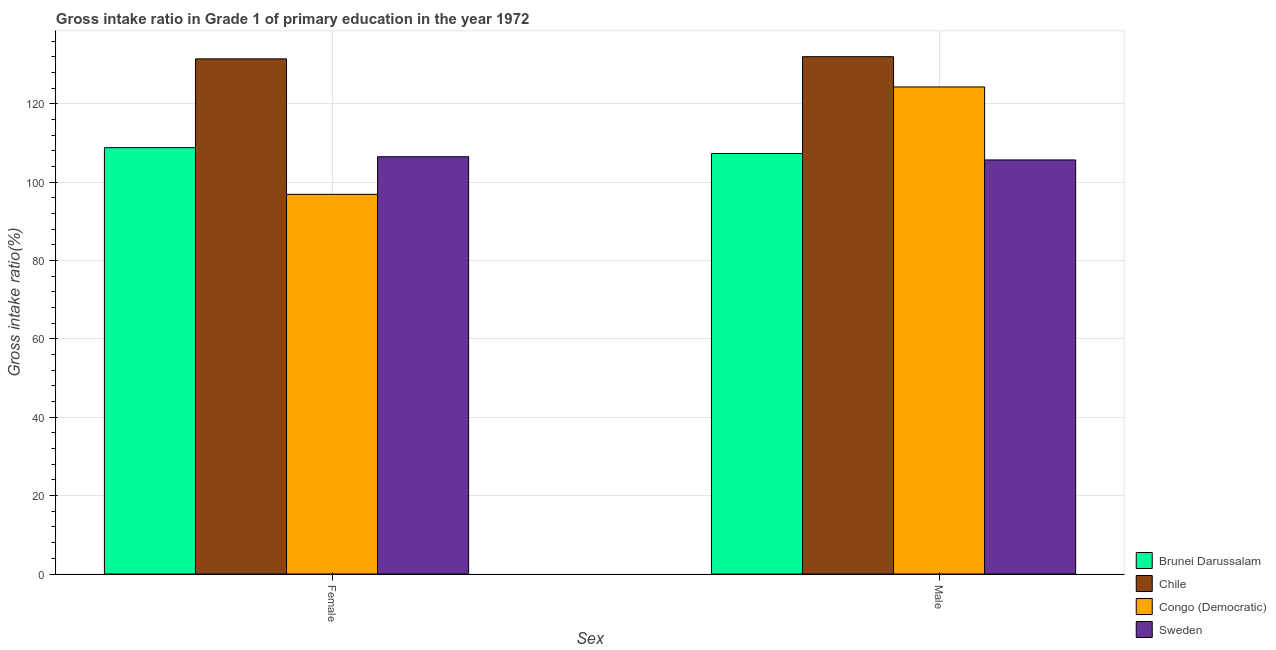How many different coloured bars are there?
Your answer should be very brief. 4. How many groups of bars are there?
Make the answer very short. 2. Are the number of bars per tick equal to the number of legend labels?
Ensure brevity in your answer.  Yes. How many bars are there on the 1st tick from the right?
Provide a succinct answer. 4. What is the label of the 1st group of bars from the left?
Provide a short and direct response. Female. What is the gross intake ratio(male) in Brunei Darussalam?
Your answer should be very brief. 107.36. Across all countries, what is the maximum gross intake ratio(female)?
Your answer should be compact. 131.51. Across all countries, what is the minimum gross intake ratio(female)?
Provide a succinct answer. 96.92. In which country was the gross intake ratio(female) maximum?
Offer a terse response. Chile. In which country was the gross intake ratio(female) minimum?
Keep it short and to the point. Congo (Democratic). What is the total gross intake ratio(male) in the graph?
Ensure brevity in your answer.  469.47. What is the difference between the gross intake ratio(female) in Sweden and that in Congo (Democratic)?
Your answer should be very brief. 9.6. What is the difference between the gross intake ratio(male) in Congo (Democratic) and the gross intake ratio(female) in Brunei Darussalam?
Make the answer very short. 15.5. What is the average gross intake ratio(female) per country?
Give a very brief answer. 110.95. What is the difference between the gross intake ratio(male) and gross intake ratio(female) in Brunei Darussalam?
Your response must be concise. -1.48. In how many countries, is the gross intake ratio(female) greater than 100 %?
Give a very brief answer. 3. What is the ratio of the gross intake ratio(male) in Congo (Democratic) to that in Sweden?
Offer a terse response. 1.18. Is the gross intake ratio(male) in Brunei Darussalam less than that in Congo (Democratic)?
Your response must be concise. Yes. What does the 3rd bar from the left in Male represents?
Ensure brevity in your answer.  Congo (Democratic). What does the 3rd bar from the right in Male represents?
Provide a succinct answer. Chile. How many bars are there?
Ensure brevity in your answer.  8. How many countries are there in the graph?
Give a very brief answer. 4. What is the difference between two consecutive major ticks on the Y-axis?
Offer a terse response. 20. Are the values on the major ticks of Y-axis written in scientific E-notation?
Ensure brevity in your answer.  No. Does the graph contain any zero values?
Make the answer very short. No. Does the graph contain grids?
Keep it short and to the point. Yes. Where does the legend appear in the graph?
Ensure brevity in your answer.  Bottom right. How many legend labels are there?
Provide a short and direct response. 4. How are the legend labels stacked?
Your response must be concise. Vertical. What is the title of the graph?
Offer a terse response. Gross intake ratio in Grade 1 of primary education in the year 1972. What is the label or title of the X-axis?
Your answer should be compact. Sex. What is the label or title of the Y-axis?
Keep it short and to the point. Gross intake ratio(%). What is the Gross intake ratio(%) in Brunei Darussalam in Female?
Provide a short and direct response. 108.84. What is the Gross intake ratio(%) of Chile in Female?
Provide a succinct answer. 131.51. What is the Gross intake ratio(%) in Congo (Democratic) in Female?
Your answer should be very brief. 96.92. What is the Gross intake ratio(%) of Sweden in Female?
Offer a terse response. 106.53. What is the Gross intake ratio(%) in Brunei Darussalam in Male?
Offer a terse response. 107.36. What is the Gross intake ratio(%) in Chile in Male?
Ensure brevity in your answer.  132.07. What is the Gross intake ratio(%) in Congo (Democratic) in Male?
Ensure brevity in your answer.  124.34. What is the Gross intake ratio(%) of Sweden in Male?
Provide a succinct answer. 105.71. Across all Sex, what is the maximum Gross intake ratio(%) of Brunei Darussalam?
Your answer should be compact. 108.84. Across all Sex, what is the maximum Gross intake ratio(%) of Chile?
Your answer should be compact. 132.07. Across all Sex, what is the maximum Gross intake ratio(%) of Congo (Democratic)?
Offer a terse response. 124.34. Across all Sex, what is the maximum Gross intake ratio(%) of Sweden?
Keep it short and to the point. 106.53. Across all Sex, what is the minimum Gross intake ratio(%) of Brunei Darussalam?
Your response must be concise. 107.36. Across all Sex, what is the minimum Gross intake ratio(%) in Chile?
Keep it short and to the point. 131.51. Across all Sex, what is the minimum Gross intake ratio(%) in Congo (Democratic)?
Give a very brief answer. 96.92. Across all Sex, what is the minimum Gross intake ratio(%) in Sweden?
Keep it short and to the point. 105.71. What is the total Gross intake ratio(%) of Brunei Darussalam in the graph?
Your response must be concise. 216.2. What is the total Gross intake ratio(%) of Chile in the graph?
Offer a terse response. 263.58. What is the total Gross intake ratio(%) in Congo (Democratic) in the graph?
Keep it short and to the point. 221.26. What is the total Gross intake ratio(%) in Sweden in the graph?
Offer a terse response. 212.24. What is the difference between the Gross intake ratio(%) of Brunei Darussalam in Female and that in Male?
Your answer should be compact. 1.48. What is the difference between the Gross intake ratio(%) of Chile in Female and that in Male?
Make the answer very short. -0.56. What is the difference between the Gross intake ratio(%) of Congo (Democratic) in Female and that in Male?
Offer a very short reply. -27.41. What is the difference between the Gross intake ratio(%) in Sweden in Female and that in Male?
Offer a terse response. 0.82. What is the difference between the Gross intake ratio(%) of Brunei Darussalam in Female and the Gross intake ratio(%) of Chile in Male?
Provide a succinct answer. -23.23. What is the difference between the Gross intake ratio(%) of Brunei Darussalam in Female and the Gross intake ratio(%) of Congo (Democratic) in Male?
Your answer should be compact. -15.5. What is the difference between the Gross intake ratio(%) of Brunei Darussalam in Female and the Gross intake ratio(%) of Sweden in Male?
Keep it short and to the point. 3.13. What is the difference between the Gross intake ratio(%) of Chile in Female and the Gross intake ratio(%) of Congo (Democratic) in Male?
Offer a very short reply. 7.17. What is the difference between the Gross intake ratio(%) in Chile in Female and the Gross intake ratio(%) in Sweden in Male?
Keep it short and to the point. 25.8. What is the difference between the Gross intake ratio(%) in Congo (Democratic) in Female and the Gross intake ratio(%) in Sweden in Male?
Provide a short and direct response. -8.78. What is the average Gross intake ratio(%) of Brunei Darussalam per Sex?
Provide a succinct answer. 108.1. What is the average Gross intake ratio(%) of Chile per Sex?
Give a very brief answer. 131.79. What is the average Gross intake ratio(%) in Congo (Democratic) per Sex?
Make the answer very short. 110.63. What is the average Gross intake ratio(%) in Sweden per Sex?
Provide a short and direct response. 106.12. What is the difference between the Gross intake ratio(%) in Brunei Darussalam and Gross intake ratio(%) in Chile in Female?
Give a very brief answer. -22.67. What is the difference between the Gross intake ratio(%) in Brunei Darussalam and Gross intake ratio(%) in Congo (Democratic) in Female?
Keep it short and to the point. 11.92. What is the difference between the Gross intake ratio(%) of Brunei Darussalam and Gross intake ratio(%) of Sweden in Female?
Keep it short and to the point. 2.31. What is the difference between the Gross intake ratio(%) in Chile and Gross intake ratio(%) in Congo (Democratic) in Female?
Keep it short and to the point. 34.58. What is the difference between the Gross intake ratio(%) of Chile and Gross intake ratio(%) of Sweden in Female?
Make the answer very short. 24.98. What is the difference between the Gross intake ratio(%) of Congo (Democratic) and Gross intake ratio(%) of Sweden in Female?
Offer a terse response. -9.6. What is the difference between the Gross intake ratio(%) of Brunei Darussalam and Gross intake ratio(%) of Chile in Male?
Provide a succinct answer. -24.71. What is the difference between the Gross intake ratio(%) of Brunei Darussalam and Gross intake ratio(%) of Congo (Democratic) in Male?
Your answer should be compact. -16.98. What is the difference between the Gross intake ratio(%) of Brunei Darussalam and Gross intake ratio(%) of Sweden in Male?
Make the answer very short. 1.65. What is the difference between the Gross intake ratio(%) of Chile and Gross intake ratio(%) of Congo (Democratic) in Male?
Provide a short and direct response. 7.73. What is the difference between the Gross intake ratio(%) of Chile and Gross intake ratio(%) of Sweden in Male?
Offer a terse response. 26.36. What is the difference between the Gross intake ratio(%) of Congo (Democratic) and Gross intake ratio(%) of Sweden in Male?
Offer a very short reply. 18.63. What is the ratio of the Gross intake ratio(%) of Brunei Darussalam in Female to that in Male?
Your answer should be very brief. 1.01. What is the ratio of the Gross intake ratio(%) of Chile in Female to that in Male?
Provide a succinct answer. 1. What is the ratio of the Gross intake ratio(%) in Congo (Democratic) in Female to that in Male?
Keep it short and to the point. 0.78. What is the ratio of the Gross intake ratio(%) of Sweden in Female to that in Male?
Your answer should be very brief. 1.01. What is the difference between the highest and the second highest Gross intake ratio(%) in Brunei Darussalam?
Offer a very short reply. 1.48. What is the difference between the highest and the second highest Gross intake ratio(%) in Chile?
Ensure brevity in your answer.  0.56. What is the difference between the highest and the second highest Gross intake ratio(%) of Congo (Democratic)?
Offer a very short reply. 27.41. What is the difference between the highest and the second highest Gross intake ratio(%) of Sweden?
Your response must be concise. 0.82. What is the difference between the highest and the lowest Gross intake ratio(%) of Brunei Darussalam?
Keep it short and to the point. 1.48. What is the difference between the highest and the lowest Gross intake ratio(%) in Chile?
Provide a short and direct response. 0.56. What is the difference between the highest and the lowest Gross intake ratio(%) in Congo (Democratic)?
Offer a very short reply. 27.41. What is the difference between the highest and the lowest Gross intake ratio(%) of Sweden?
Offer a terse response. 0.82. 